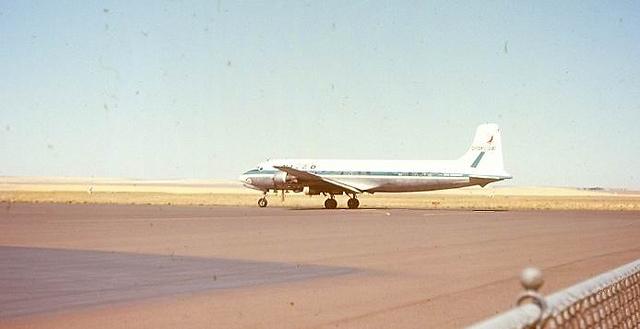Is the plane in the middle of nowhere?
Concise answer only. Yes. How many planes are shown?
Concise answer only. 1. Is there a man-made structure visible in the background behind the plane?
Quick response, please. No. 